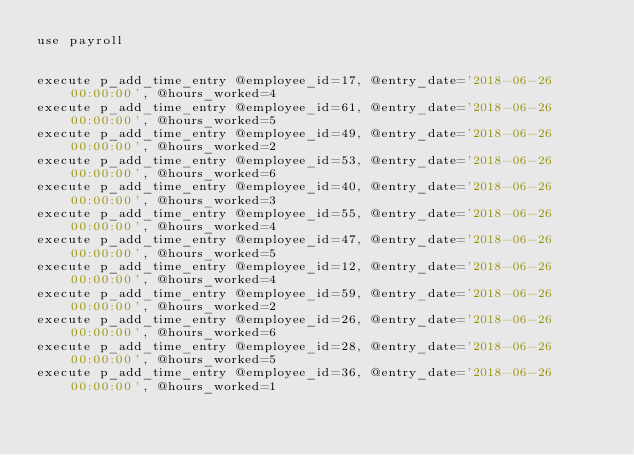<code> <loc_0><loc_0><loc_500><loc_500><_SQL_>use payroll


execute p_add_time_entry @employee_id=17, @entry_date='2018-06-26 00:00:00', @hours_worked=4
execute p_add_time_entry @employee_id=61, @entry_date='2018-06-26 00:00:00', @hours_worked=5
execute p_add_time_entry @employee_id=49, @entry_date='2018-06-26 00:00:00', @hours_worked=2
execute p_add_time_entry @employee_id=53, @entry_date='2018-06-26 00:00:00', @hours_worked=6
execute p_add_time_entry @employee_id=40, @entry_date='2018-06-26 00:00:00', @hours_worked=3
execute p_add_time_entry @employee_id=55, @entry_date='2018-06-26 00:00:00', @hours_worked=4
execute p_add_time_entry @employee_id=47, @entry_date='2018-06-26 00:00:00', @hours_worked=5
execute p_add_time_entry @employee_id=12, @entry_date='2018-06-26 00:00:00', @hours_worked=4
execute p_add_time_entry @employee_id=59, @entry_date='2018-06-26 00:00:00', @hours_worked=2
execute p_add_time_entry @employee_id=26, @entry_date='2018-06-26 00:00:00', @hours_worked=6
execute p_add_time_entry @employee_id=28, @entry_date='2018-06-26 00:00:00', @hours_worked=5
execute p_add_time_entry @employee_id=36, @entry_date='2018-06-26 00:00:00', @hours_worked=1</code> 